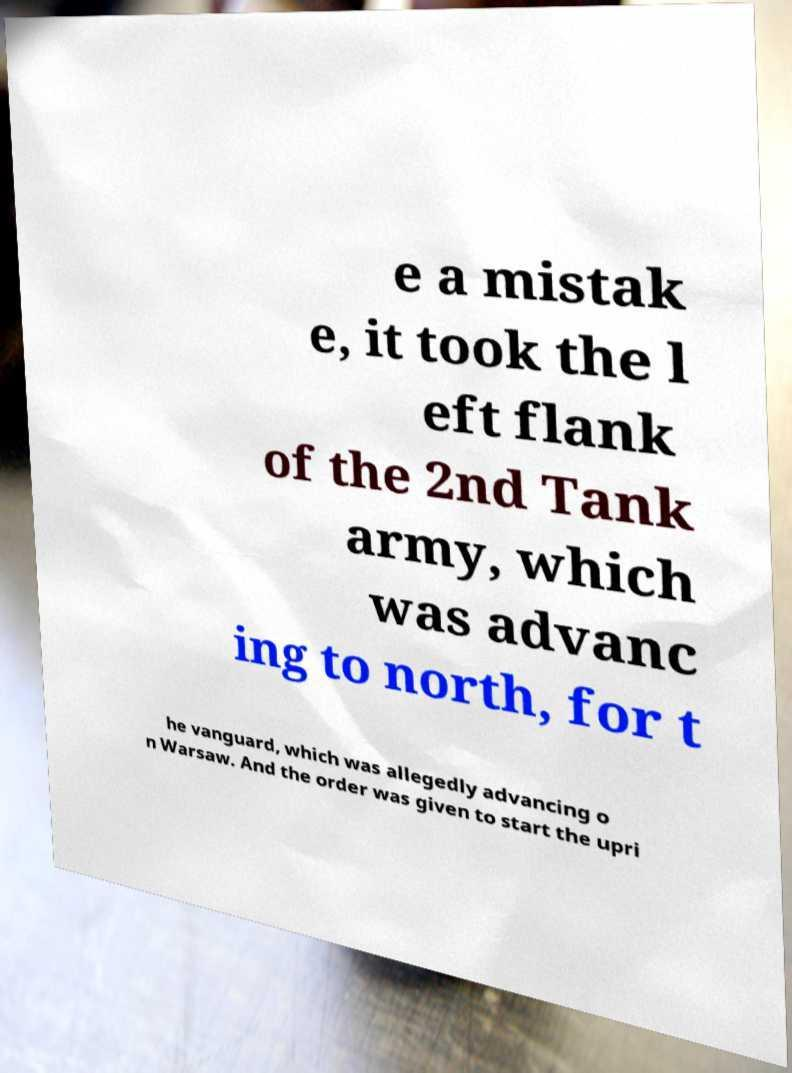I need the written content from this picture converted into text. Can you do that? e a mistak e, it took the l eft flank of the 2nd Tank army, which was advanc ing to north, for t he vanguard, which was allegedly advancing o n Warsaw. And the order was given to start the upri 